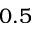Convert formula to latex. <formula><loc_0><loc_0><loc_500><loc_500>0 . 5</formula> 